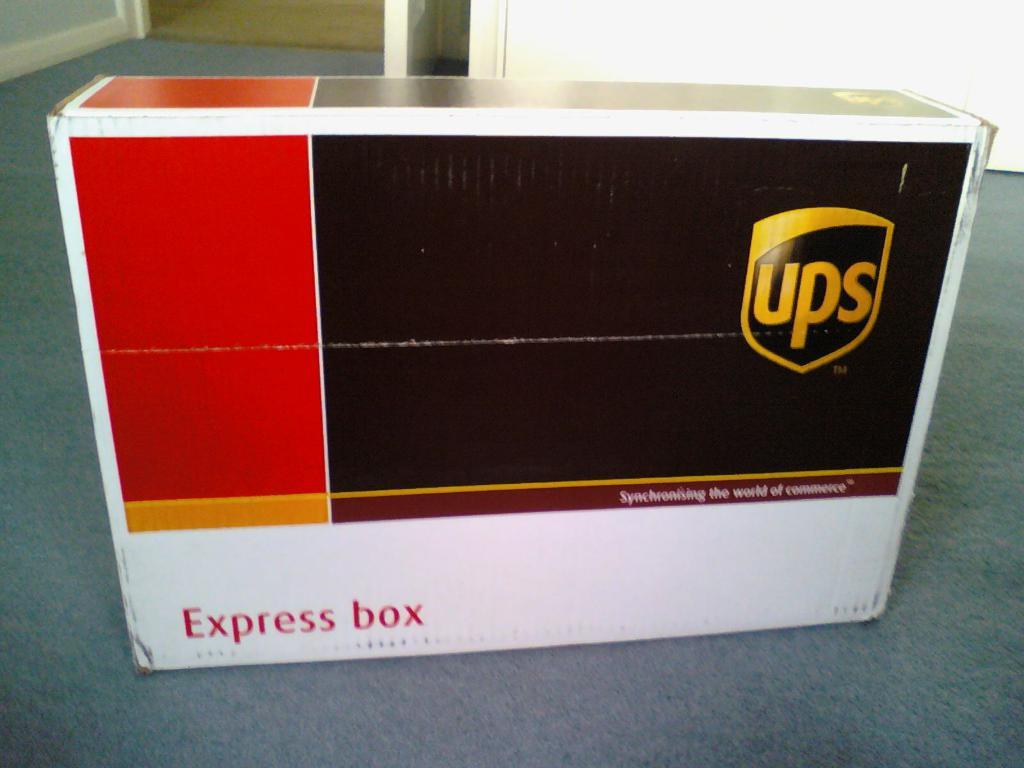What kind of box is this?
Ensure brevity in your answer.  Express. Who sent this box?
Your answer should be compact. Ups. 